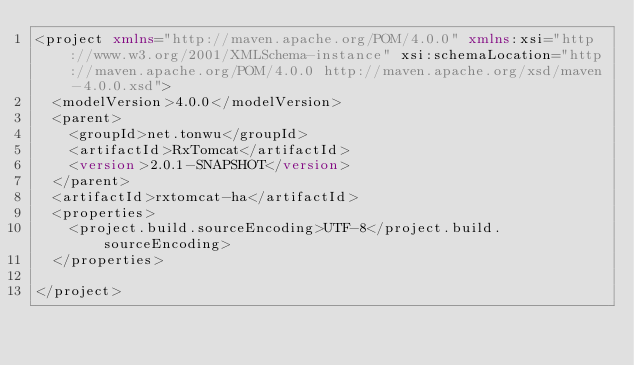Convert code to text. <code><loc_0><loc_0><loc_500><loc_500><_XML_><project xmlns="http://maven.apache.org/POM/4.0.0" xmlns:xsi="http://www.w3.org/2001/XMLSchema-instance" xsi:schemaLocation="http://maven.apache.org/POM/4.0.0 http://maven.apache.org/xsd/maven-4.0.0.xsd">
  <modelVersion>4.0.0</modelVersion>
  <parent>
    <groupId>net.tonwu</groupId>
    <artifactId>RxTomcat</artifactId>
    <version>2.0.1-SNAPSHOT</version>
  </parent>
  <artifactId>rxtomcat-ha</artifactId>
  <properties>
    <project.build.sourceEncoding>UTF-8</project.build.sourceEncoding>
  </properties>

</project></code> 